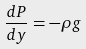Convert formula to latex. <formula><loc_0><loc_0><loc_500><loc_500>\frac { d P } { d y } = - \rho g</formula> 